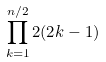<formula> <loc_0><loc_0><loc_500><loc_500>\prod _ { k = 1 } ^ { n / 2 } 2 ( 2 k - 1 )</formula> 